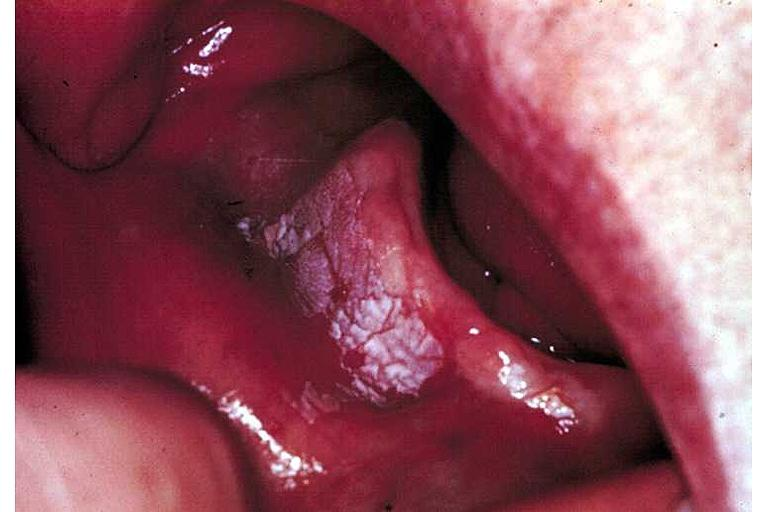where is this?
Answer the question using a single word or phrase. Oral 